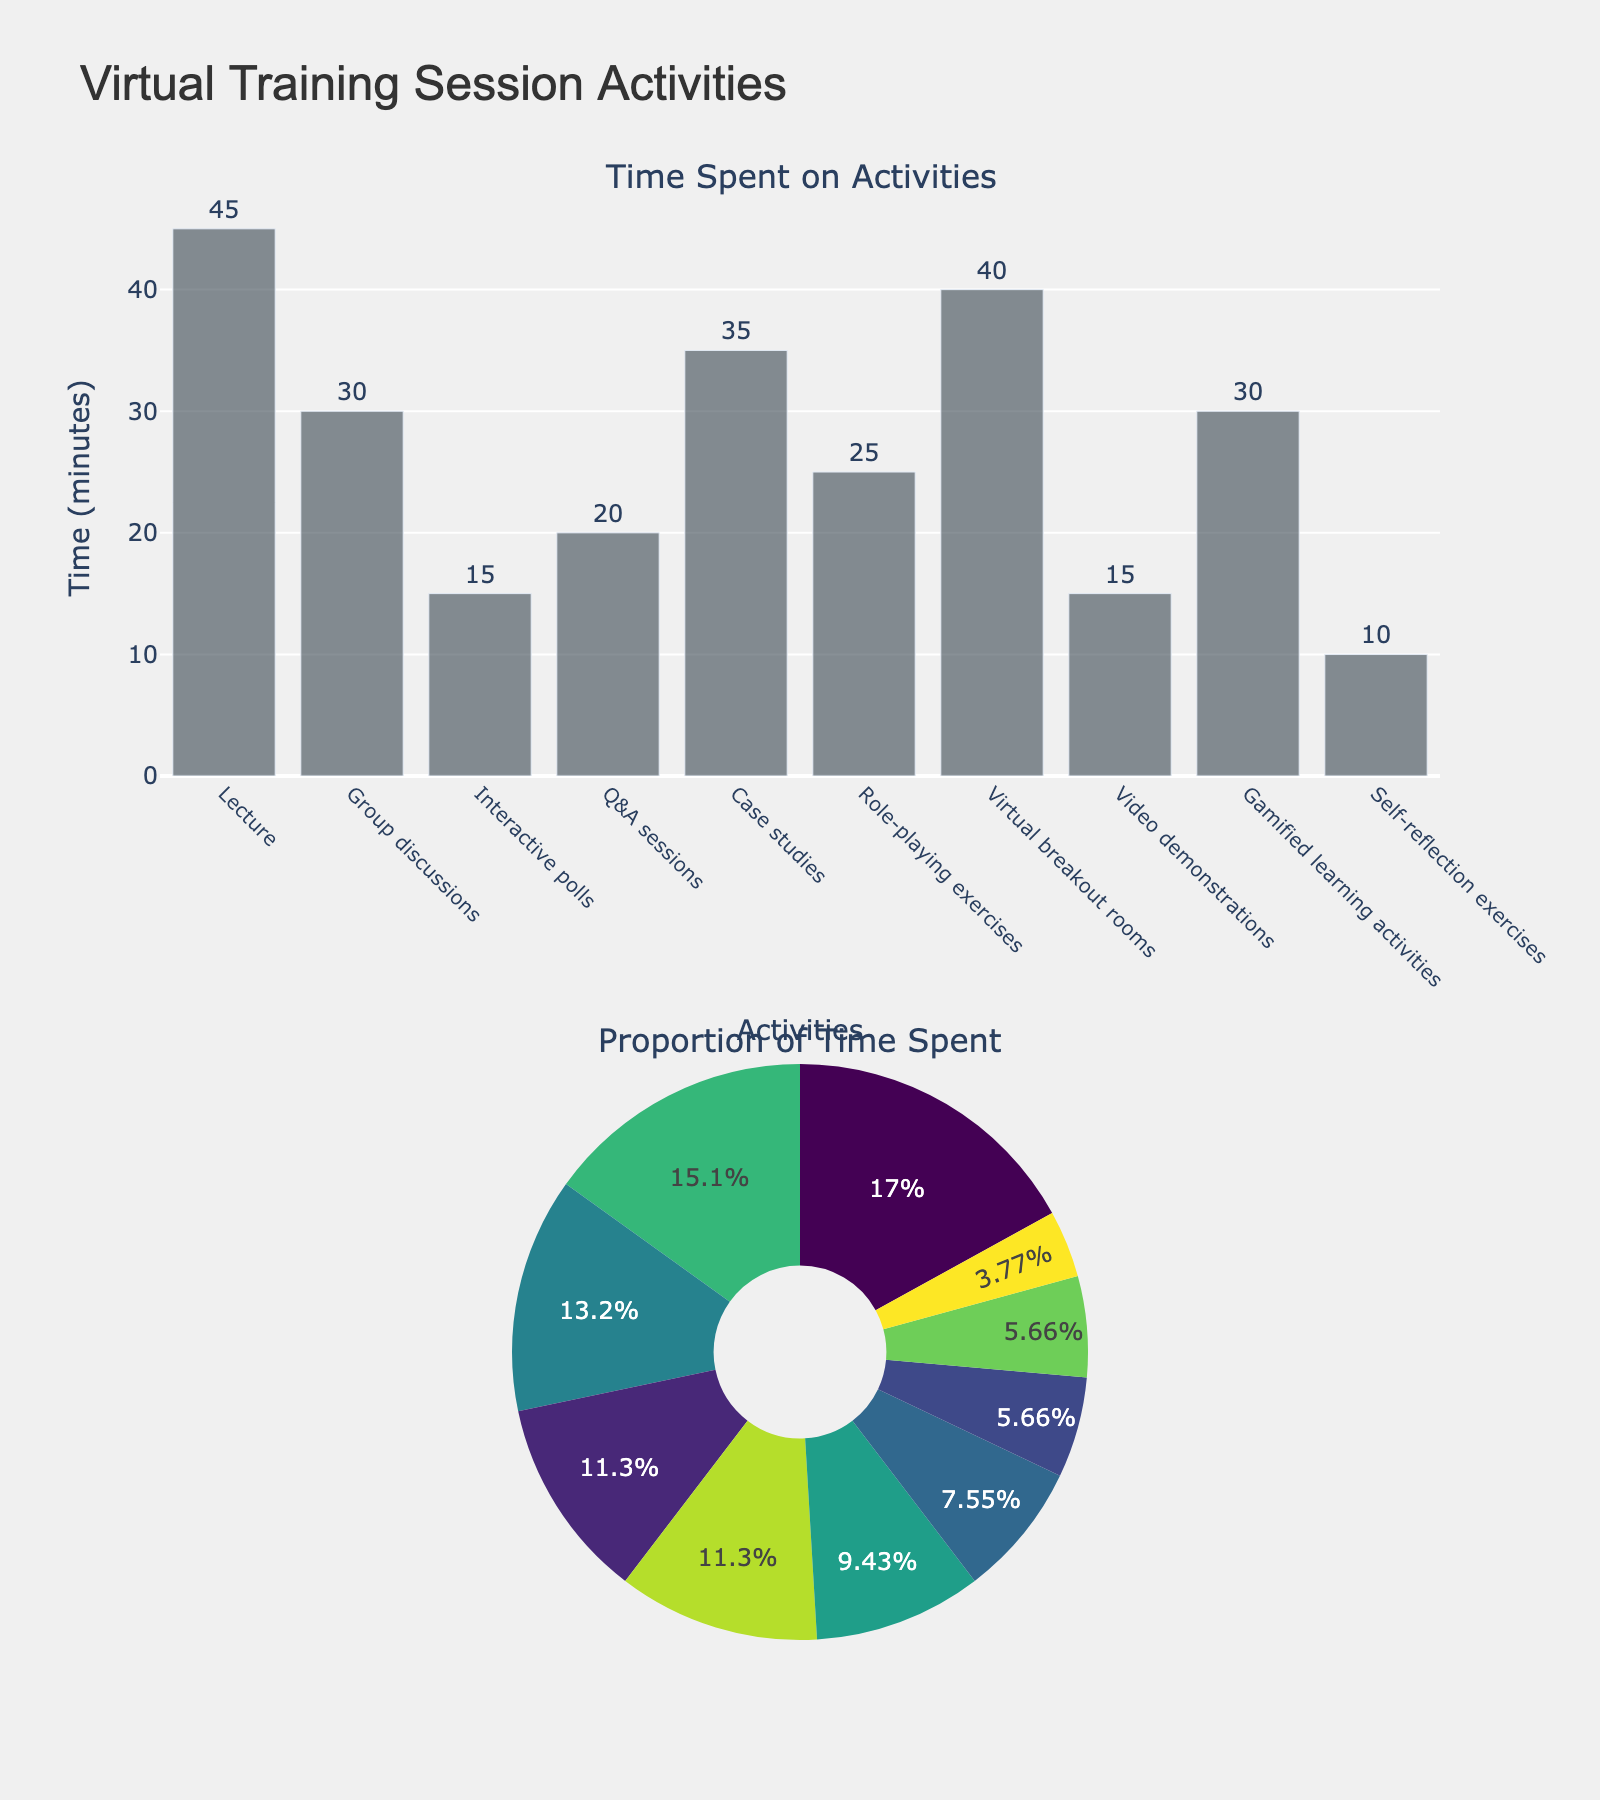Which activity has the highest time spent? By looking at the bar length and the proportion in the pie chart, we can see that the 'Lecture' activity has the longest bar and the largest segment in the pie chart.
Answer: Lecture What is the total time spent on interactive activities (Group discussions, Interactive polls, Q&A sessions, Virtual breakout rooms, Role-playing exercises, and Gamified learning activities)? To get the total time, sum up the time for each relevant activity: Group discussions (30) + Interactive polls (15) + Q&A sessions (20) + Virtual breakout rooms (40) + Role-playing exercises (25) + Gamified learning activities (30) = 160 minutes.
Answer: 160 minutes Which two activities have the smallest time allocation? By looking at the bar lengths and pie chart proportions, 'Interactive polls' and 'Self-reflection exercises' have the smallest segments.
Answer: Interactive polls and Self-reflection exercises How does the time spent on Case studies compare to that on Group discussions? From the bar lengths and pie chart proportions, 'Case studies' has 35 minutes, and 'Group discussions' has 30 minutes. Therefore, time spent on Case studies is slightly more than Group discussions.
Answer: Case studies What is the average time spent on all activities? Sum all times and divide by the number of activities: (45 + 30 + 15 + 20 + 35 + 25 + 40 + 15 + 30 + 10) / 10 = 265 / 10 = 26.5 minutes.
Answer: 26.5 minutes Which activity has an equal time allocation to Video demonstrations? From both the bar chart and pie chart, 'Interactive polls' also has a time allocation of 15 minutes, the same as 'Video demonstrations'.
Answer: Interactive polls What is the combined time spent on Lecture and Virtual breakout rooms? Adding the times for 'Lecture' (45 minutes) and 'Virtual breakout rooms' (40 minutes) gives a total of 85 minutes.
Answer: 85 minutes What is the ratio of time spent on Role-playing exercises to Q&A Sessions? 'Role-playing exercises' has 25 minutes, and 'Q&A Sessions' has 20 minutes. The ratio is 25/20, which simplifies to 5/4 or 1.25.
Answer: 1.25 Which activity takes up exactly double the time of Self-reflection exercises? The 'Self-reflection exercises' are 10 minutes. From both the bar and pie charts, 'Interactive polls' takes up 15 minutes, which is greater than 10, while no other activity is exactly double 10 minutes.
Answer: No activity How does the total time of Lecture, Video demonstrations, and Interactive polls compare to Virtual breakout rooms? Add the times for Lecture (45), Video demonstrations (15), and Interactive polls (15): 45 + 15 + 15 = 75 minutes. Virtual breakout rooms alone is 40 minutes. So, 75 minutes is greater than 40 minutes.
Answer: 75 > 40 